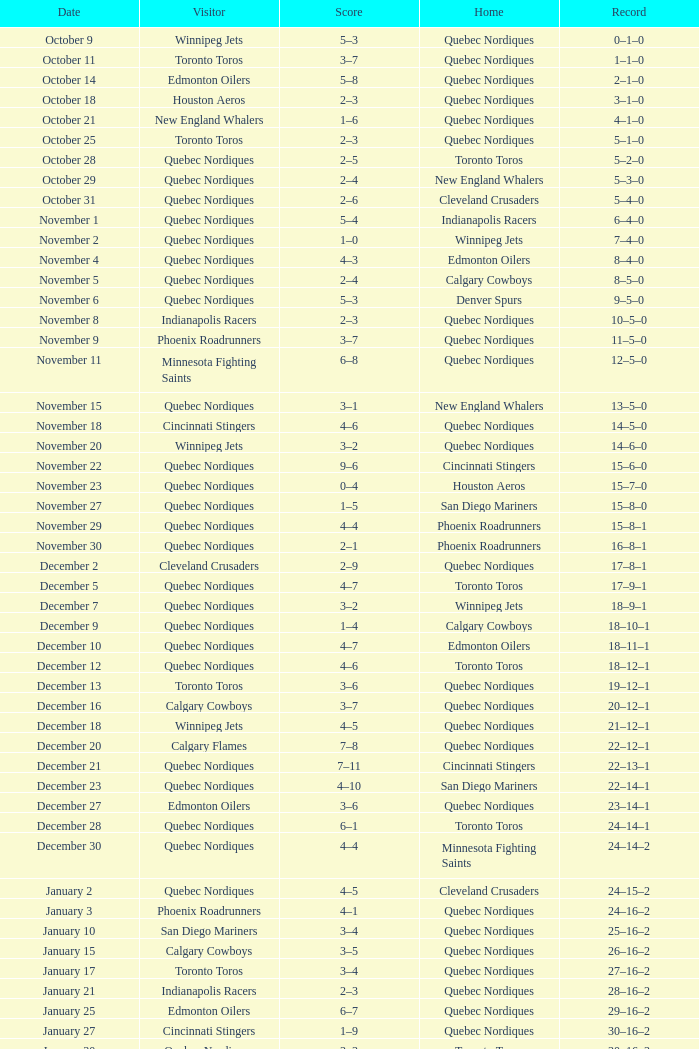When did the game with a final score of 2-1 take place? November 30. 